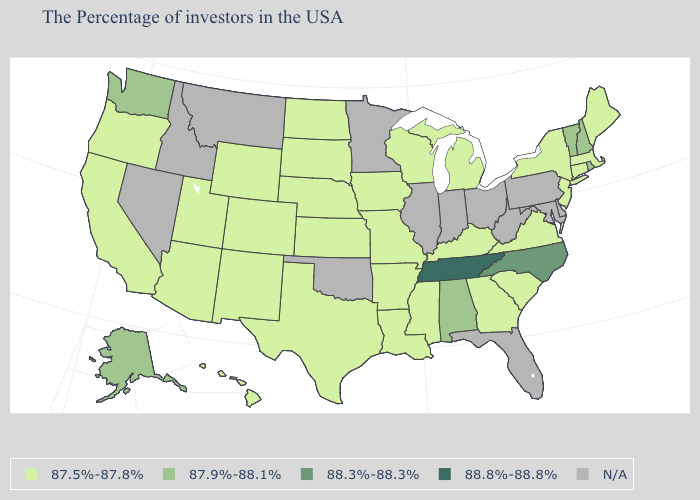Name the states that have a value in the range 87.9%-88.1%?
Answer briefly. Rhode Island, New Hampshire, Vermont, Alabama, Washington, Alaska. Name the states that have a value in the range 88.8%-88.8%?
Write a very short answer. Tennessee. Name the states that have a value in the range 87.9%-88.1%?
Concise answer only. Rhode Island, New Hampshire, Vermont, Alabama, Washington, Alaska. Which states have the highest value in the USA?
Short answer required. Tennessee. How many symbols are there in the legend?
Be succinct. 5. Which states have the lowest value in the South?
Concise answer only. Virginia, South Carolina, Georgia, Kentucky, Mississippi, Louisiana, Arkansas, Texas. What is the highest value in states that border Kentucky?
Concise answer only. 88.8%-88.8%. What is the value of Kentucky?
Short answer required. 87.5%-87.8%. What is the lowest value in the MidWest?
Give a very brief answer. 87.5%-87.8%. Which states have the lowest value in the USA?
Keep it brief. Maine, Massachusetts, Connecticut, New York, New Jersey, Virginia, South Carolina, Georgia, Michigan, Kentucky, Wisconsin, Mississippi, Louisiana, Missouri, Arkansas, Iowa, Kansas, Nebraska, Texas, South Dakota, North Dakota, Wyoming, Colorado, New Mexico, Utah, Arizona, California, Oregon, Hawaii. Among the states that border Vermont , does New Hampshire have the lowest value?
Be succinct. No. Name the states that have a value in the range N/A?
Answer briefly. Delaware, Maryland, Pennsylvania, West Virginia, Ohio, Florida, Indiana, Illinois, Minnesota, Oklahoma, Montana, Idaho, Nevada. Which states have the highest value in the USA?
Give a very brief answer. Tennessee. What is the value of California?
Give a very brief answer. 87.5%-87.8%. Is the legend a continuous bar?
Answer briefly. No. 